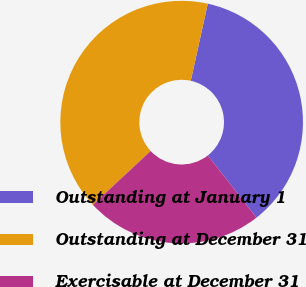Convert chart to OTSL. <chart><loc_0><loc_0><loc_500><loc_500><pie_chart><fcel>Outstanding at January 1<fcel>Outstanding at December 31<fcel>Exercisable at December 31<nl><fcel>35.96%<fcel>40.39%<fcel>23.65%<nl></chart> 